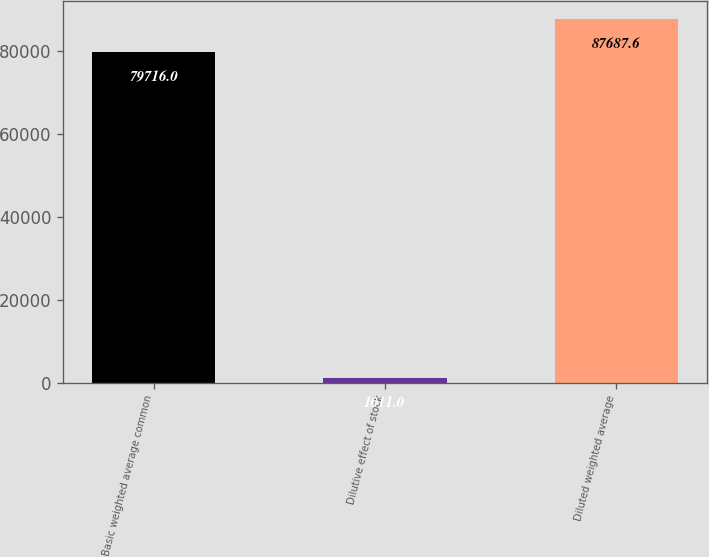Convert chart to OTSL. <chart><loc_0><loc_0><loc_500><loc_500><bar_chart><fcel>Basic weighted average common<fcel>Dilutive effect of stock<fcel>Diluted weighted average<nl><fcel>79716<fcel>1011<fcel>87687.6<nl></chart> 